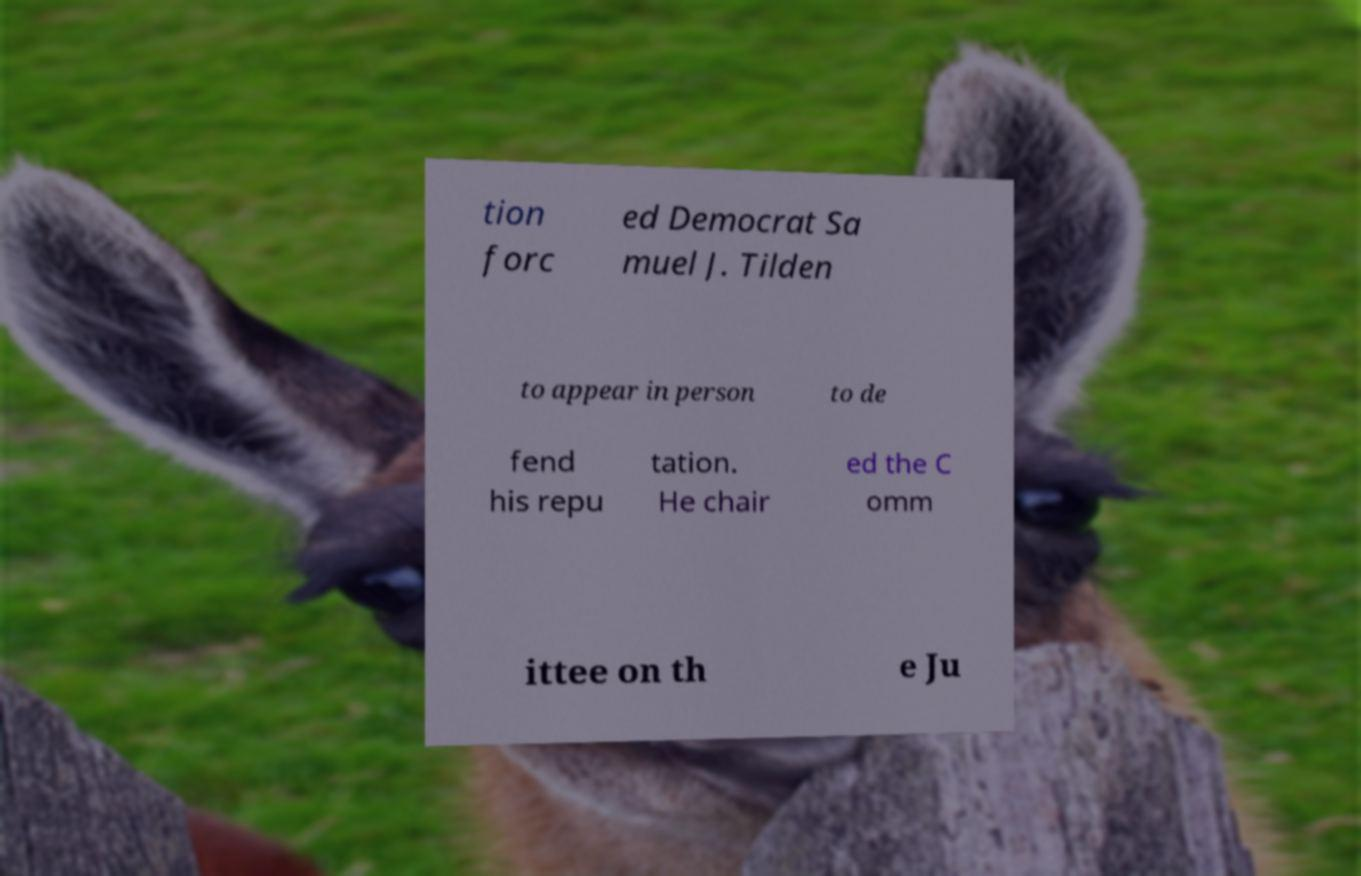I need the written content from this picture converted into text. Can you do that? tion forc ed Democrat Sa muel J. Tilden to appear in person to de fend his repu tation. He chair ed the C omm ittee on th e Ju 